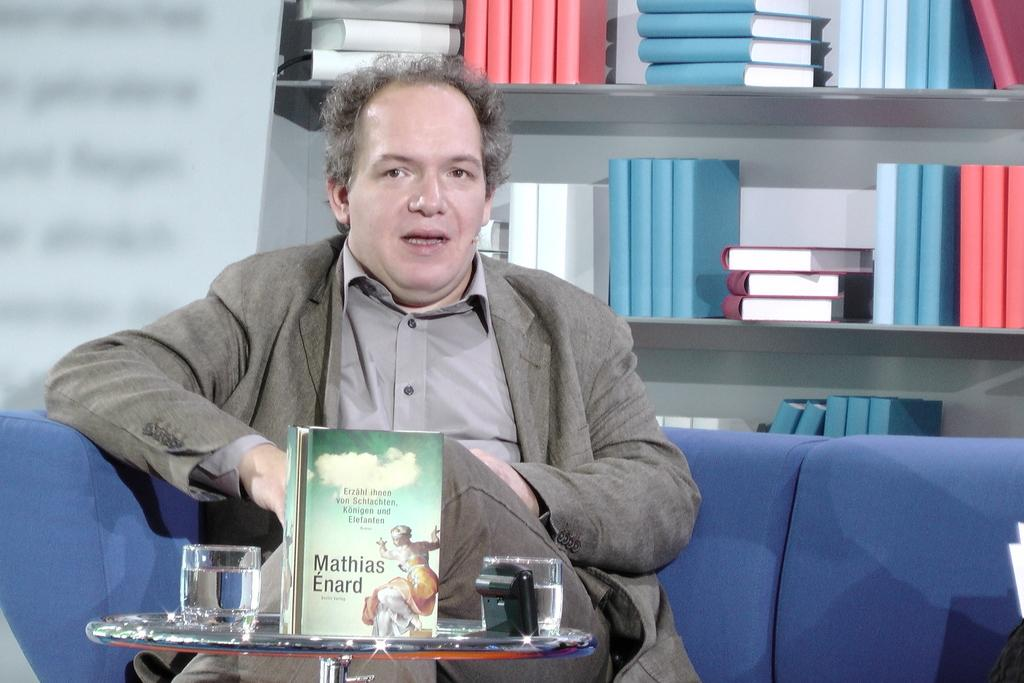What is the person in the image doing? The person is sitting on the sofa. What can be seen in the background of the image? There are books in the shelves in the background. What is on the table in the image? There is a book and two glasses on the table. What type of brain can be seen in the image? There is no brain present in the image. How many cattle are visible in the image? There are no cattle present in the image. 